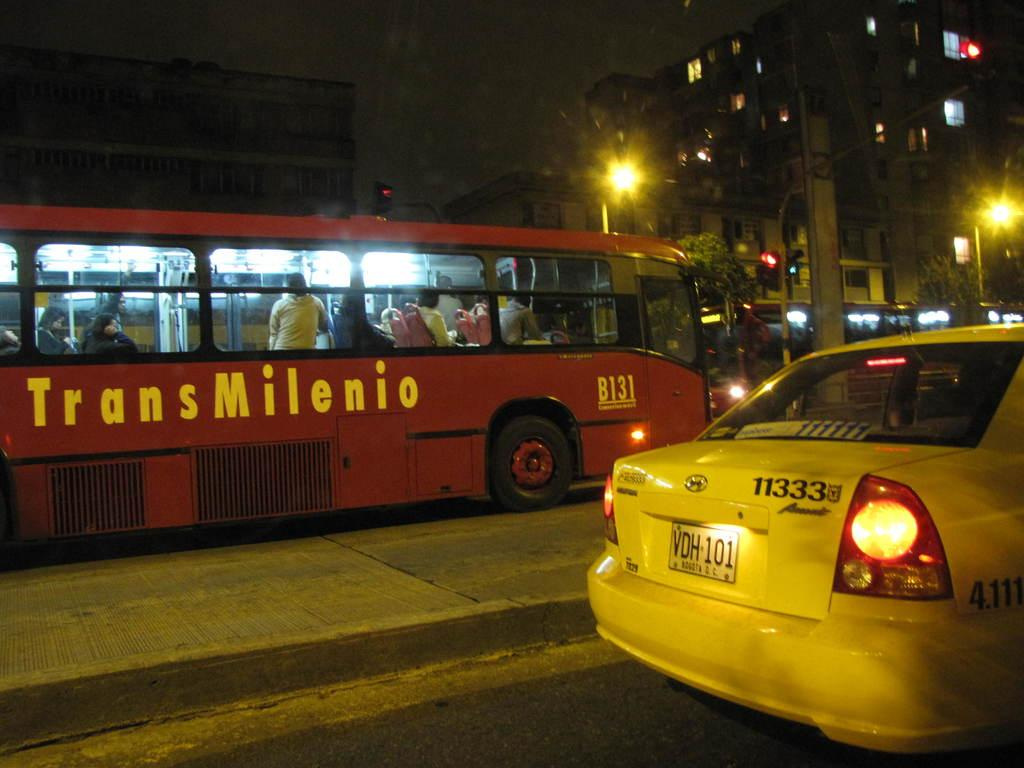<image>
Provide a brief description of the given image. A yellow cab and a red bus marked TransMilenio on a night-time street. 